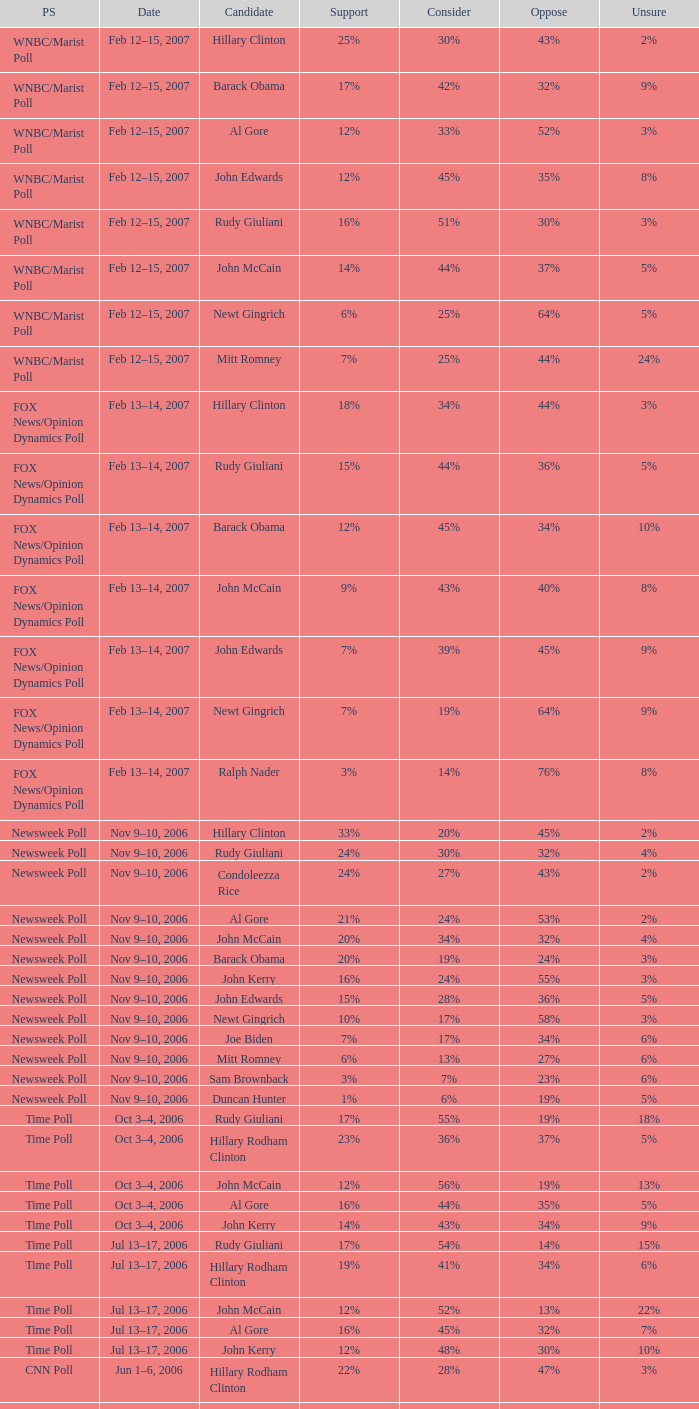Could you parse the entire table as a dict? {'header': ['PS', 'Date', 'Candidate', 'Support', 'Consider', 'Oppose', 'Unsure'], 'rows': [['WNBC/Marist Poll', 'Feb 12–15, 2007', 'Hillary Clinton', '25%', '30%', '43%', '2%'], ['WNBC/Marist Poll', 'Feb 12–15, 2007', 'Barack Obama', '17%', '42%', '32%', '9%'], ['WNBC/Marist Poll', 'Feb 12–15, 2007', 'Al Gore', '12%', '33%', '52%', '3%'], ['WNBC/Marist Poll', 'Feb 12–15, 2007', 'John Edwards', '12%', '45%', '35%', '8%'], ['WNBC/Marist Poll', 'Feb 12–15, 2007', 'Rudy Giuliani', '16%', '51%', '30%', '3%'], ['WNBC/Marist Poll', 'Feb 12–15, 2007', 'John McCain', '14%', '44%', '37%', '5%'], ['WNBC/Marist Poll', 'Feb 12–15, 2007', 'Newt Gingrich', '6%', '25%', '64%', '5%'], ['WNBC/Marist Poll', 'Feb 12–15, 2007', 'Mitt Romney', '7%', '25%', '44%', '24%'], ['FOX News/Opinion Dynamics Poll', 'Feb 13–14, 2007', 'Hillary Clinton', '18%', '34%', '44%', '3%'], ['FOX News/Opinion Dynamics Poll', 'Feb 13–14, 2007', 'Rudy Giuliani', '15%', '44%', '36%', '5%'], ['FOX News/Opinion Dynamics Poll', 'Feb 13–14, 2007', 'Barack Obama', '12%', '45%', '34%', '10%'], ['FOX News/Opinion Dynamics Poll', 'Feb 13–14, 2007', 'John McCain', '9%', '43%', '40%', '8%'], ['FOX News/Opinion Dynamics Poll', 'Feb 13–14, 2007', 'John Edwards', '7%', '39%', '45%', '9%'], ['FOX News/Opinion Dynamics Poll', 'Feb 13–14, 2007', 'Newt Gingrich', '7%', '19%', '64%', '9%'], ['FOX News/Opinion Dynamics Poll', 'Feb 13–14, 2007', 'Ralph Nader', '3%', '14%', '76%', '8%'], ['Newsweek Poll', 'Nov 9–10, 2006', 'Hillary Clinton', '33%', '20%', '45%', '2%'], ['Newsweek Poll', 'Nov 9–10, 2006', 'Rudy Giuliani', '24%', '30%', '32%', '4%'], ['Newsweek Poll', 'Nov 9–10, 2006', 'Condoleezza Rice', '24%', '27%', '43%', '2%'], ['Newsweek Poll', 'Nov 9–10, 2006', 'Al Gore', '21%', '24%', '53%', '2%'], ['Newsweek Poll', 'Nov 9–10, 2006', 'John McCain', '20%', '34%', '32%', '4%'], ['Newsweek Poll', 'Nov 9–10, 2006', 'Barack Obama', '20%', '19%', '24%', '3%'], ['Newsweek Poll', 'Nov 9–10, 2006', 'John Kerry', '16%', '24%', '55%', '3%'], ['Newsweek Poll', 'Nov 9–10, 2006', 'John Edwards', '15%', '28%', '36%', '5%'], ['Newsweek Poll', 'Nov 9–10, 2006', 'Newt Gingrich', '10%', '17%', '58%', '3%'], ['Newsweek Poll', 'Nov 9–10, 2006', 'Joe Biden', '7%', '17%', '34%', '6%'], ['Newsweek Poll', 'Nov 9–10, 2006', 'Mitt Romney', '6%', '13%', '27%', '6%'], ['Newsweek Poll', 'Nov 9–10, 2006', 'Sam Brownback', '3%', '7%', '23%', '6%'], ['Newsweek Poll', 'Nov 9–10, 2006', 'Duncan Hunter', '1%', '6%', '19%', '5%'], ['Time Poll', 'Oct 3–4, 2006', 'Rudy Giuliani', '17%', '55%', '19%', '18%'], ['Time Poll', 'Oct 3–4, 2006', 'Hillary Rodham Clinton', '23%', '36%', '37%', '5%'], ['Time Poll', 'Oct 3–4, 2006', 'John McCain', '12%', '56%', '19%', '13%'], ['Time Poll', 'Oct 3–4, 2006', 'Al Gore', '16%', '44%', '35%', '5%'], ['Time Poll', 'Oct 3–4, 2006', 'John Kerry', '14%', '43%', '34%', '9%'], ['Time Poll', 'Jul 13–17, 2006', 'Rudy Giuliani', '17%', '54%', '14%', '15%'], ['Time Poll', 'Jul 13–17, 2006', 'Hillary Rodham Clinton', '19%', '41%', '34%', '6%'], ['Time Poll', 'Jul 13–17, 2006', 'John McCain', '12%', '52%', '13%', '22%'], ['Time Poll', 'Jul 13–17, 2006', 'Al Gore', '16%', '45%', '32%', '7%'], ['Time Poll', 'Jul 13–17, 2006', 'John Kerry', '12%', '48%', '30%', '10%'], ['CNN Poll', 'Jun 1–6, 2006', 'Hillary Rodham Clinton', '22%', '28%', '47%', '3%'], ['CNN Poll', 'Jun 1–6, 2006', 'Al Gore', '17%', '32%', '48%', '3%'], ['CNN Poll', 'Jun 1–6, 2006', 'John Kerry', '14%', '35%', '47%', '4%'], ['CNN Poll', 'Jun 1–6, 2006', 'Rudolph Giuliani', '19%', '45%', '30%', '6%'], ['CNN Poll', 'Jun 1–6, 2006', 'John McCain', '12%', '48%', '34%', '6%'], ['CNN Poll', 'Jun 1–6, 2006', 'Jeb Bush', '9%', '26%', '63%', '2%'], ['ABC News/Washington Post Poll', 'May 11–15, 2006', 'Hillary Clinton', '19%', '38%', '42%', '1%'], ['ABC News/Washington Post Poll', 'May 11–15, 2006', 'John McCain', '9%', '57%', '28%', '6%'], ['FOX News/Opinion Dynamics Poll', 'Feb 7–8, 2006', 'Hillary Clinton', '35%', '19%', '44%', '2%'], ['FOX News/Opinion Dynamics Poll', 'Feb 7–8, 2006', 'Rudy Giuliani', '33%', '38%', '24%', '6%'], ['FOX News/Opinion Dynamics Poll', 'Feb 7–8, 2006', 'John McCain', '30%', '40%', '22%', '7%'], ['FOX News/Opinion Dynamics Poll', 'Feb 7–8, 2006', 'John Kerry', '29%', '23%', '45%', '3%'], ['FOX News/Opinion Dynamics Poll', 'Feb 7–8, 2006', 'Condoleezza Rice', '14%', '38%', '46%', '3%'], ['CNN/USA Today/Gallup Poll', 'Jan 20–22, 2006', 'Hillary Rodham Clinton', '16%', '32%', '51%', '1%'], ['Diageo/Hotline Poll', 'Nov 11–15, 2005', 'John McCain', '23%', '46%', '15%', '15%'], ['CNN/USA Today/Gallup Poll', 'May 20–22, 2005', 'Hillary Rodham Clinton', '28%', '31%', '40%', '1%'], ['CNN/USA Today/Gallup Poll', 'Jun 9–10, 2003', 'Hillary Rodham Clinton', '20%', '33%', '45%', '2%']]} What percentage of people were opposed to the candidate based on the Time Poll poll that showed 6% of people were unsure? 34%. 